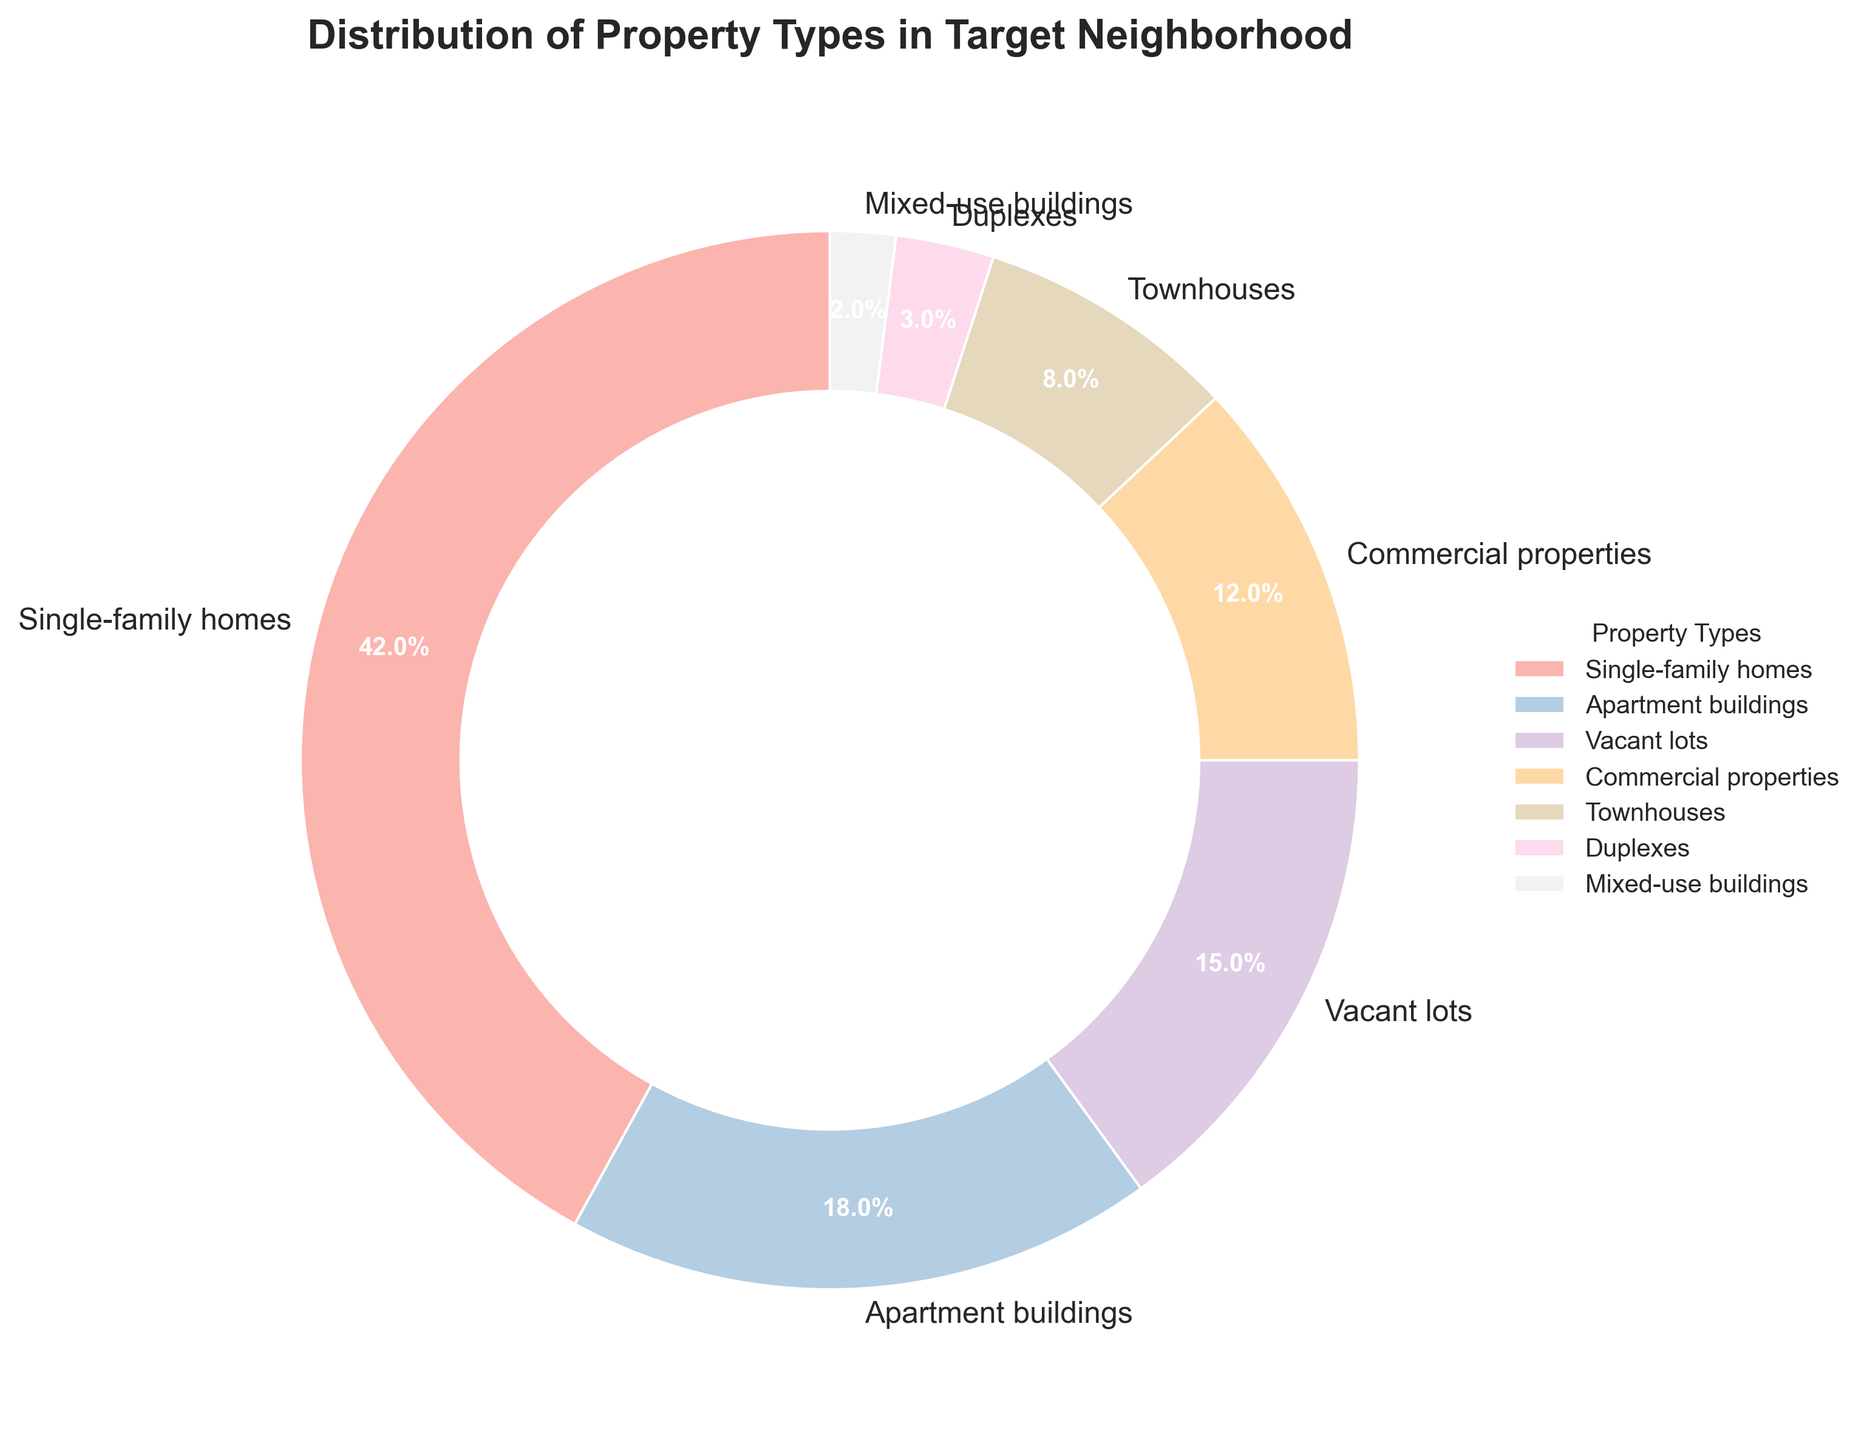Which property type has the highest percentage? The pie chart shows that Single-family homes have the largest wedge, which corresponds to the highest percentage.
Answer: Single-family homes Which two property types together make up more than half of the neighborhood? Adding the percentages of Single-family homes (42%) and Apartment buildings (18%) results in 60%, which is more than half.
Answer: Single-family homes and Apartment buildings What percentage of properties are either Commercial properties or Duplexes? The sum of the percentages of Commercial properties (12%) and Duplexes (3%) is 15%.
Answer: 15% What is the ratio of Single-family homes to Townhouses? The percentage of Single-family homes is 42% and that of Townhouses is 8%. The ratio is 42:8 or simplified, 21:4.
Answer: 21:4 Which property type occupies the smallest percentage of the neighborhood? The pie chart shows that Mixed-use buildings have the smallest wedge, thus the smallest percentage.
Answer: Mixed-use buildings How much larger is the percentage of Vacant lots compared to Mixed-use buildings? The percentage of Vacant lots is 15% and Mixed-use buildings is 2%. The difference is 15% - 2% = 13%.
Answer: 13% Which property types together account for exactly one-third of the neighborhood? Adding the percentages of Vacant lots (15%), Commercial properties (12%), and Townhouses (8%) results in 35%, which is roughly one-third.
Answer: Vacant lots, Commercial properties, and Townhouses What percentage of the neighborhood is comprised of Mixed-use buildings, Duplexes, and Townhouses combined? Adding the percentages of Mixed-use buildings (2%), Duplexes (3%), and Townhouses (8%) results in 13%.
Answer: 13% Are Vacant lots more common than Apartment buildings? The percentage of Vacant lots is 15% while Apartment buildings are 18%. Thus, Vacant lots are less common.
Answer: No What is the sum of the percentages of all property types together? Adding all the percentages together: 42% + 18% + 15% + 12% + 8% + 3% + 2% = 100%.
Answer: 100% 